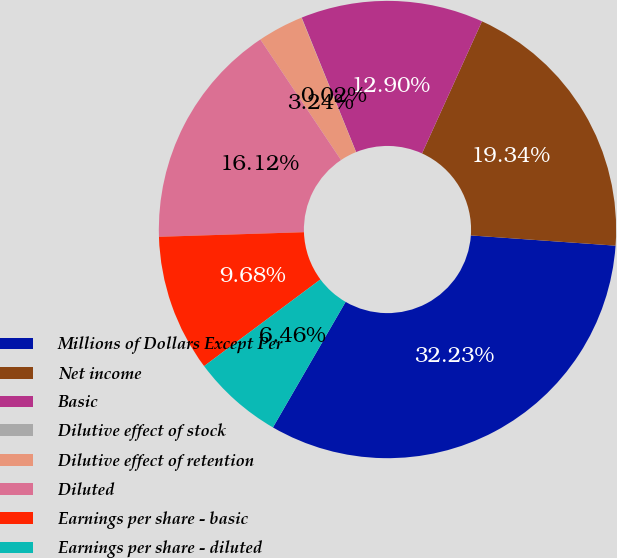Convert chart to OTSL. <chart><loc_0><loc_0><loc_500><loc_500><pie_chart><fcel>Millions of Dollars Except Per<fcel>Net income<fcel>Basic<fcel>Dilutive effect of stock<fcel>Dilutive effect of retention<fcel>Diluted<fcel>Earnings per share - basic<fcel>Earnings per share - diluted<nl><fcel>32.22%<fcel>19.34%<fcel>12.9%<fcel>0.02%<fcel>3.24%<fcel>16.12%<fcel>9.68%<fcel>6.46%<nl></chart> 